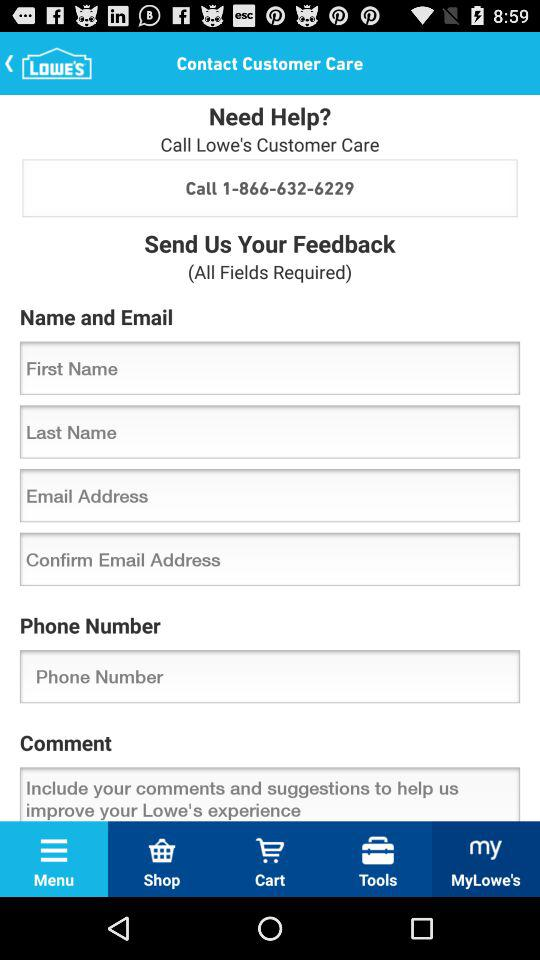Where is the nearest Lowe's location?
When the provided information is insufficient, respond with <no answer>. <no answer> 